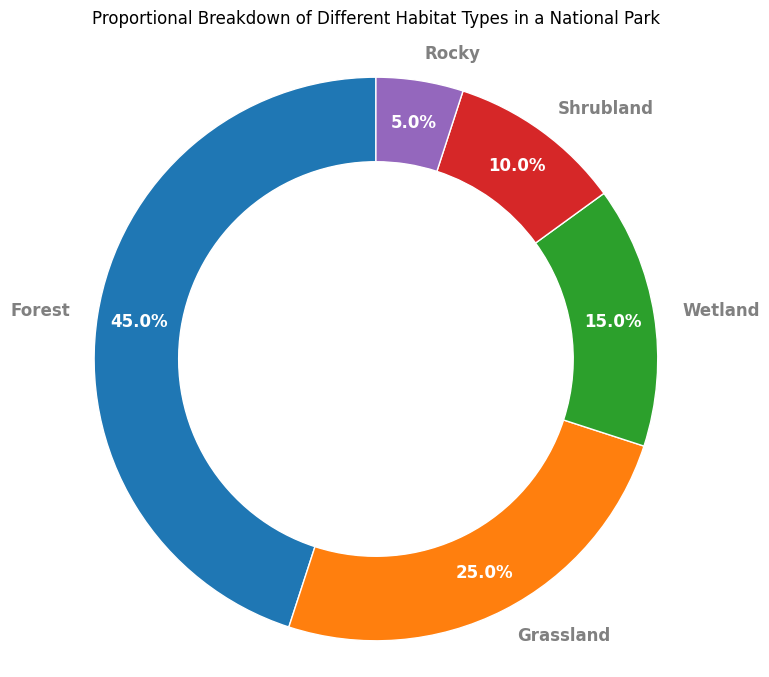What is the largest habitat type in the national park? The largest habitat type is the one with the highest percentage. From the ring chart, Forest has the highest percentage.
Answer: Forest Which habitat types combined make up half of the national park? To find which habitat types combined make up 50%, add the percentages incrementally from the largest upwards: 45% (Forest) + 25% (Grassland) = 70%. The two habitat types, Forest and Grassland, together make up more than half the park.
Answer: Forest and Grassland How does the area covered by Wetland compare to that covered by Shrubland? Compare the percentages of Wetland (15%) and Shrubland (10%) from the ring chart. 15% is greater than 10%.
Answer: Wetland covers more area than Shrubland What is the combined proportion of Shrubland and Rocky habitats? Sum the percentages of Shrubland (10%) and Rocky (5%) habitats: 10% + 5% = 15%.
Answer: 15% Which habitat type has the smallest coverage in the national park? The smallest habitat type is the one with the lowest percentage. From the ring chart, Rocky has the lowest percentage.
Answer: Rocky What is the difference in coverage between Grassland and Wetland habitats? Subtract the percentage of Wetland (15%) from Grassland (25%): 25% - 15% = 10%.
Answer: 10% How much larger is the Forest habitat compared to the Shrubland habitat? Subtract the percentage of Shrubland (10%) from Forest (45%): 45% - 10% = 35%.
Answer: 35% What is the total percentage of natural habitats excluding Forest? Subtract the Forest percentage (45%) from the total (100%): 100% - 45% = 55%.
Answer: 55% Which two habitat types together cover 40% of the national park? Check the combinations: Shrubland (10%) + Grassland (25%) + Rocky (5%) = 40%. Thus, Shrubland and Grassland together cover 40%.
Answer: Shrubland and Grassland If Forests were to increase by 10%, what would their new percentage be? Add 10% to the current Forest percentage (45%): 45% + 10% = 55%.
Answer: 55% 